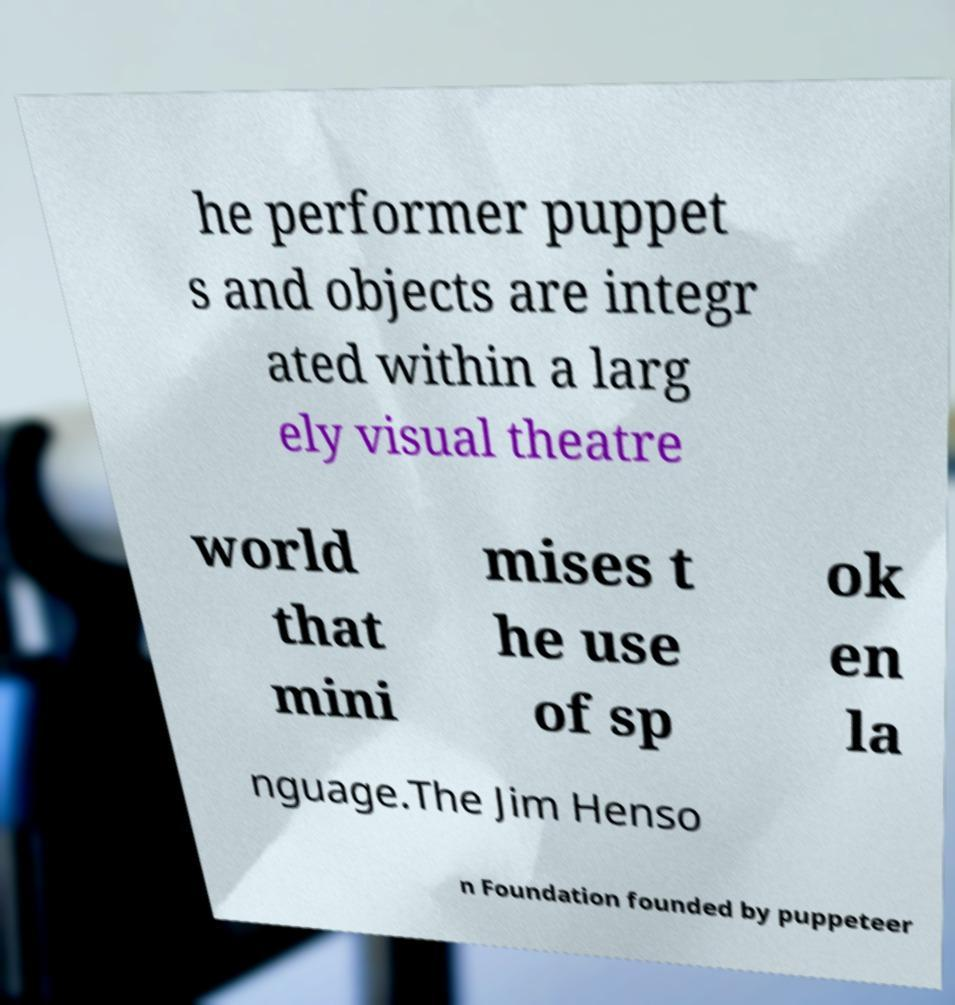What messages or text are displayed in this image? I need them in a readable, typed format. he performer puppet s and objects are integr ated within a larg ely visual theatre world that mini mises t he use of sp ok en la nguage.The Jim Henso n Foundation founded by puppeteer 